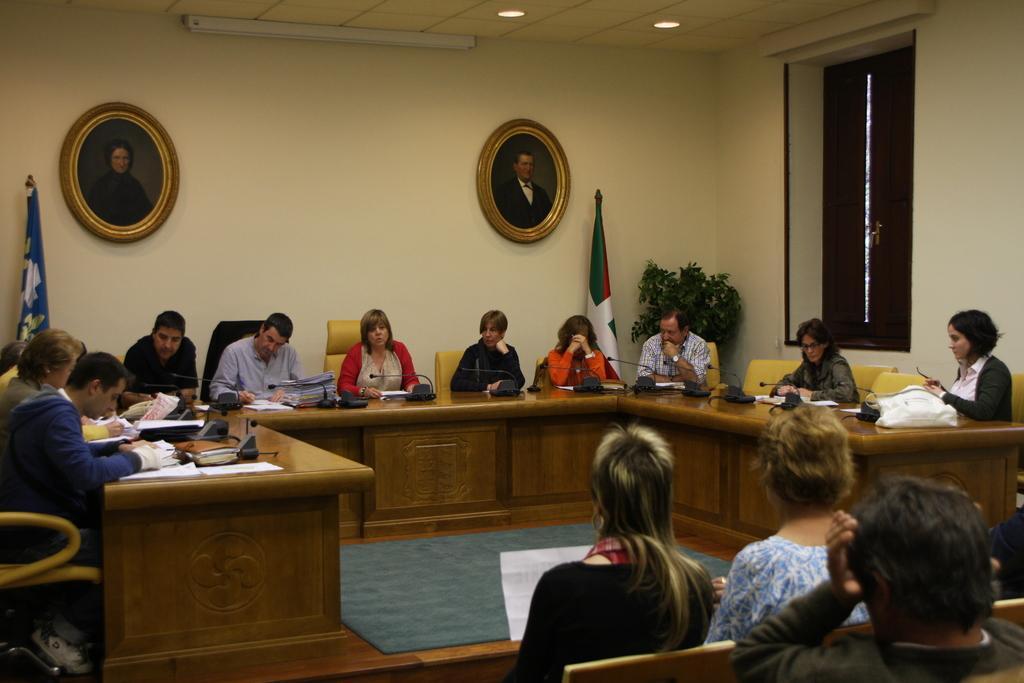Please provide a concise description of this image. On the right side, there are persons sitting. In the background, there are persons sitting on chairs around a table on which, there are mice and documents, there are two flags, a plant, photo frames on the wall, a window and lights attached to the roof. 